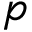Convert formula to latex. <formula><loc_0><loc_0><loc_500><loc_500>p</formula> 